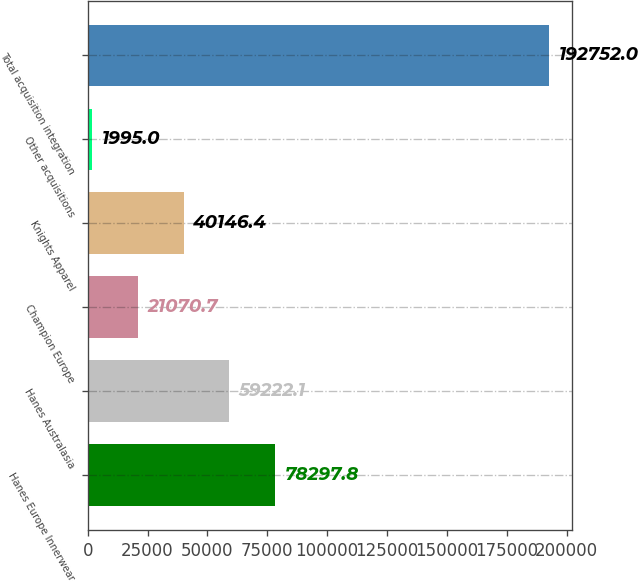Convert chart to OTSL. <chart><loc_0><loc_0><loc_500><loc_500><bar_chart><fcel>Hanes Europe Innerwear<fcel>Hanes Australasia<fcel>Champion Europe<fcel>Knights Apparel<fcel>Other acquisitions<fcel>Total acquisition integration<nl><fcel>78297.8<fcel>59222.1<fcel>21070.7<fcel>40146.4<fcel>1995<fcel>192752<nl></chart> 